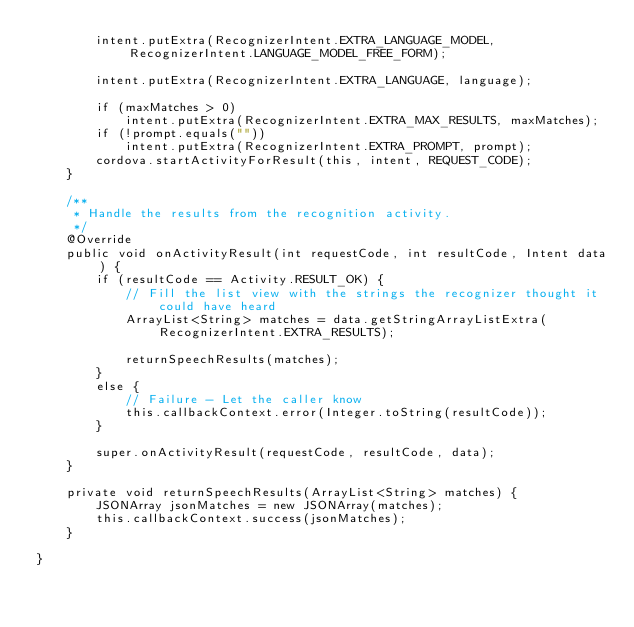Convert code to text. <code><loc_0><loc_0><loc_500><loc_500><_Java_>        intent.putExtra(RecognizerIntent.EXTRA_LANGUAGE_MODEL, RecognizerIntent.LANGUAGE_MODEL_FREE_FORM);
        
        intent.putExtra(RecognizerIntent.EXTRA_LANGUAGE, language);

        if (maxMatches > 0)
            intent.putExtra(RecognizerIntent.EXTRA_MAX_RESULTS, maxMatches);
        if (!prompt.equals(""))
            intent.putExtra(RecognizerIntent.EXTRA_PROMPT, prompt);
        cordova.startActivityForResult(this, intent, REQUEST_CODE);
    }

    /**
     * Handle the results from the recognition activity.
     */
    @Override
    public void onActivityResult(int requestCode, int resultCode, Intent data) {
        if (resultCode == Activity.RESULT_OK) {
            // Fill the list view with the strings the recognizer thought it could have heard
            ArrayList<String> matches = data.getStringArrayListExtra(RecognizerIntent.EXTRA_RESULTS);

            returnSpeechResults(matches);
        }
        else {
            // Failure - Let the caller know
            this.callbackContext.error(Integer.toString(resultCode));
        }

        super.onActivityResult(requestCode, resultCode, data);
    }

    private void returnSpeechResults(ArrayList<String> matches) {
        JSONArray jsonMatches = new JSONArray(matches);
        this.callbackContext.success(jsonMatches);
    }
    
}
</code> 